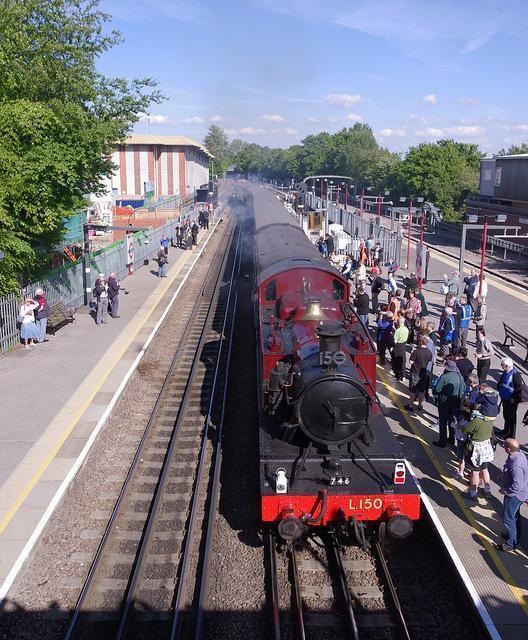How many people can you see?
Give a very brief answer. 3. 